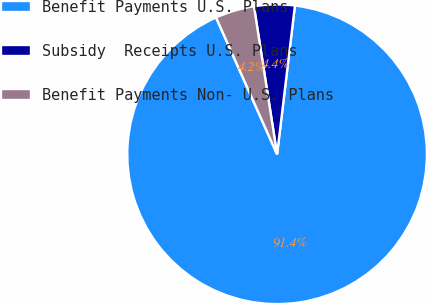<chart> <loc_0><loc_0><loc_500><loc_500><pie_chart><fcel>Benefit Payments U.S. Plans<fcel>Subsidy  Receipts U.S. Plans<fcel>Benefit Payments Non- U.S. Plans<nl><fcel>91.42%<fcel>4.37%<fcel>4.21%<nl></chart> 